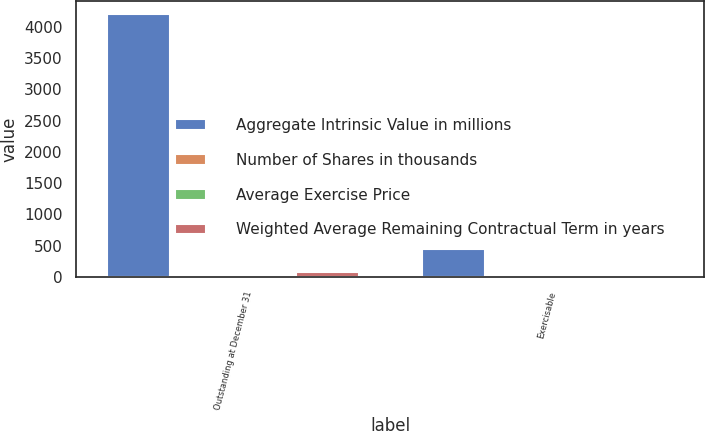Convert chart. <chart><loc_0><loc_0><loc_500><loc_500><stacked_bar_chart><ecel><fcel>Outstanding at December 31<fcel>Exercisable<nl><fcel>Aggregate Intrinsic Value in millions<fcel>4194<fcel>454<nl><fcel>Number of Shares in thousands<fcel>11.46<fcel>7.75<nl><fcel>Average Exercise Price<fcel>4.21<fcel>3.6<nl><fcel>Weighted Average Remaining Contractual Term in years<fcel>87.3<fcel>11.1<nl></chart> 